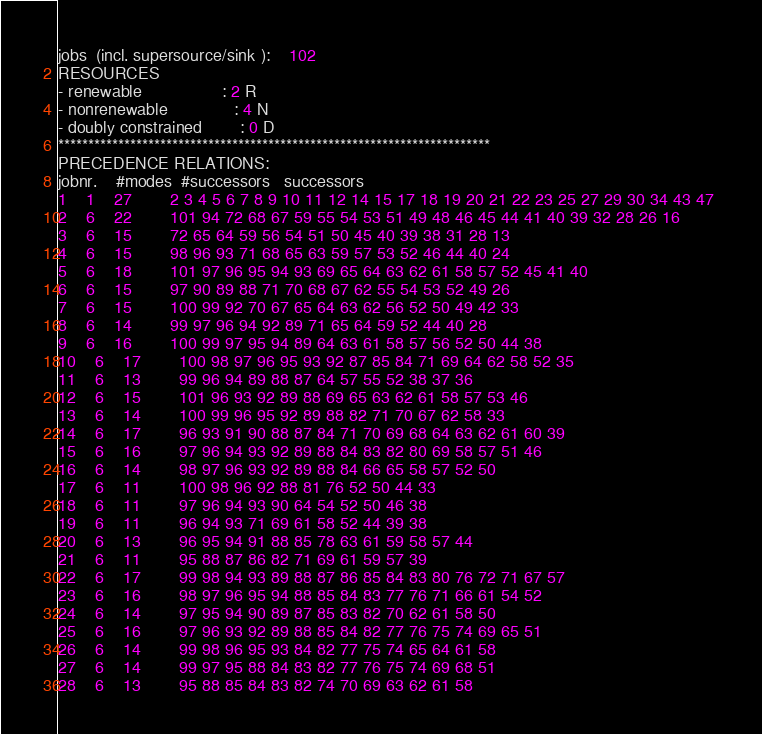Convert code to text. <code><loc_0><loc_0><loc_500><loc_500><_ObjectiveC_>jobs  (incl. supersource/sink ):	102
RESOURCES
- renewable                 : 2 R
- nonrenewable              : 4 N
- doubly constrained        : 0 D
************************************************************************
PRECEDENCE RELATIONS:
jobnr.    #modes  #successors   successors
1	1	27		2 3 4 5 6 7 8 9 10 11 12 14 15 17 18 19 20 21 22 23 25 27 29 30 34 43 47 
2	6	22		101 94 72 68 67 59 55 54 53 51 49 48 46 45 44 41 40 39 32 28 26 16 
3	6	15		72 65 64 59 56 54 51 50 45 40 39 38 31 28 13 
4	6	15		98 96 93 71 68 65 63 59 57 53 52 46 44 40 24 
5	6	18		101 97 96 95 94 93 69 65 64 63 62 61 58 57 52 45 41 40 
6	6	15		97 90 89 88 71 70 68 67 62 55 54 53 52 49 26 
7	6	15		100 99 92 70 67 65 64 63 62 56 52 50 49 42 33 
8	6	14		99 97 96 94 92 89 71 65 64 59 52 44 40 28 
9	6	16		100 99 97 95 94 89 64 63 61 58 57 56 52 50 44 38 
10	6	17		100 98 97 96 95 93 92 87 85 84 71 69 64 62 58 52 35 
11	6	13		99 96 94 89 88 87 64 57 55 52 38 37 36 
12	6	15		101 96 93 92 89 88 69 65 63 62 61 58 57 53 46 
13	6	14		100 99 96 95 92 89 88 82 71 70 67 62 58 33 
14	6	17		96 93 91 90 88 87 84 71 70 69 68 64 63 62 61 60 39 
15	6	16		97 96 94 93 92 89 88 84 83 82 80 69 58 57 51 46 
16	6	14		98 97 96 93 92 89 88 84 66 65 58 57 52 50 
17	6	11		100 98 96 92 88 81 76 52 50 44 33 
18	6	11		97 96 94 93 90 64 54 52 50 46 38 
19	6	11		96 94 93 71 69 61 58 52 44 39 38 
20	6	13		96 95 94 91 88 85 78 63 61 59 58 57 44 
21	6	11		95 88 87 86 82 71 69 61 59 57 39 
22	6	17		99 98 94 93 89 88 87 86 85 84 83 80 76 72 71 67 57 
23	6	16		98 97 96 95 94 88 85 84 83 77 76 71 66 61 54 52 
24	6	14		97 95 94 90 89 87 85 83 82 70 62 61 58 50 
25	6	16		97 96 93 92 89 88 85 84 82 77 76 75 74 69 65 51 
26	6	14		99 98 96 95 93 84 82 77 75 74 65 64 61 58 
27	6	14		99 97 95 88 84 83 82 77 76 75 74 69 68 51 
28	6	13		95 88 85 84 83 82 74 70 69 63 62 61 58 </code> 